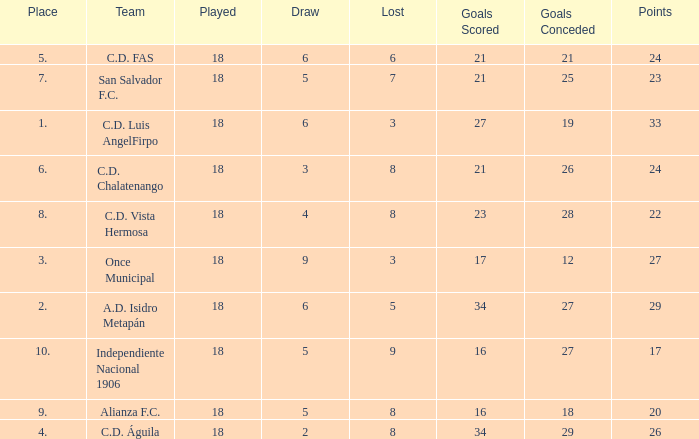What were the goal conceded that had a lost greater than 8 and more than 17 points? None. 